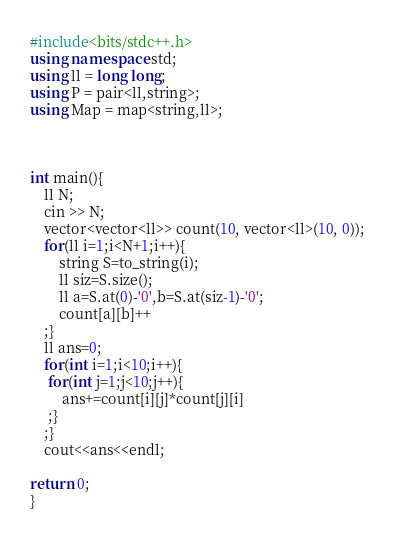Convert code to text. <code><loc_0><loc_0><loc_500><loc_500><_C++_>#include<bits/stdc++.h>
using namespace std;
using ll = long long;
using P = pair<ll,string>;
using Map = map<string,ll>;



int main(){
    ll N;
    cin >> N;
    vector<vector<ll>> count(10, vector<ll>(10, 0));
    for(ll i=1;i<N+1;i++){
        string S=to_string(i);
        ll siz=S.size();
        ll a=S.at(0)-'0',b=S.at(siz-1)-'0';
        count[a][b]++
    ;}
    ll ans=0;
    for(int i=1;i<10;i++){
     for(int j=1;j<10;j++){
         ans+=count[i][j]*count[j][i]
     ;}
    ;}
    cout<<ans<<endl;

return 0;
}  

</code> 